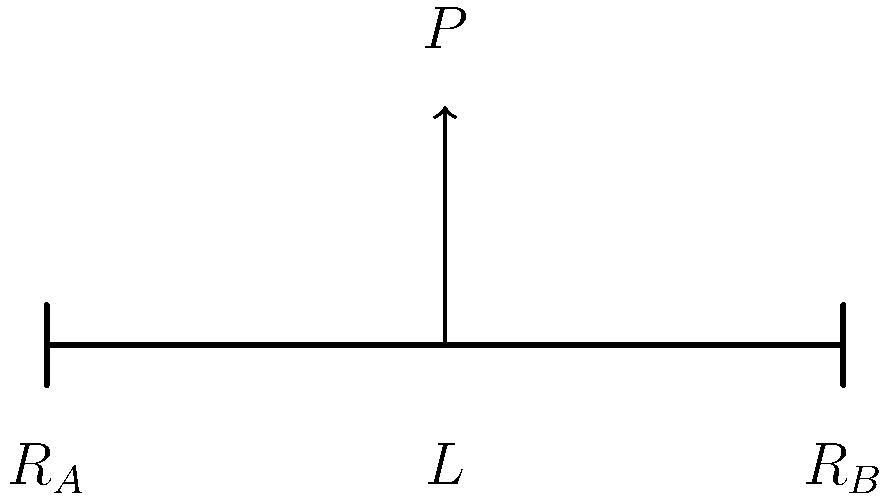In the context of Sumerian architectural practices, consider a simply supported beam of length $L$ with a point load $P$ applied at its midpoint. How would you express the reaction forces $R_A$ and $R_B$ at the supports in terms of $P$? To solve this problem, we'll use the principles of statics, which, interestingly, were likely understood intuitively by ancient Sumerian builders:

1) For a simply supported beam, the sum of the reaction forces must equal the applied load:
   $$R_A + R_B = P$$

2) The moment about any point on the beam must be zero. Let's take moments about point A:
   $$R_B \cdot L - P \cdot \frac{L}{2} = 0$$

3) Solve for $R_B$:
   $$R_B = \frac{P \cdot \frac{L}{2}}{L} = \frac{P}{2}$$

4) Since the load is at the midpoint, symmetry dictates that $R_A = R_B$:
   $$R_A = R_B = \frac{P}{2}$$

This result shows that the reaction forces are equally distributed, each supporting half of the applied load. This principle may have been used in ancient Sumerian architecture, particularly in the construction of lintels over doorways or in supporting roof beams.
Answer: $R_A = R_B = \frac{P}{2}$ 